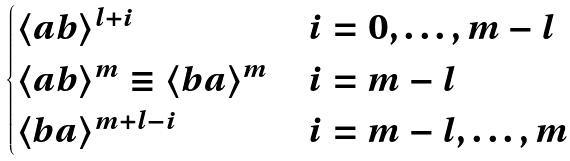<formula> <loc_0><loc_0><loc_500><loc_500>\begin{cases} \langle a b \rangle ^ { l + i } & i = 0 , \dots , m - l \\ \langle a b \rangle ^ { m } \equiv \langle b a \rangle ^ { m } & i = m - l \\ \langle b a \rangle ^ { m + l - i } & i = m - l , \dots , m \end{cases}</formula> 